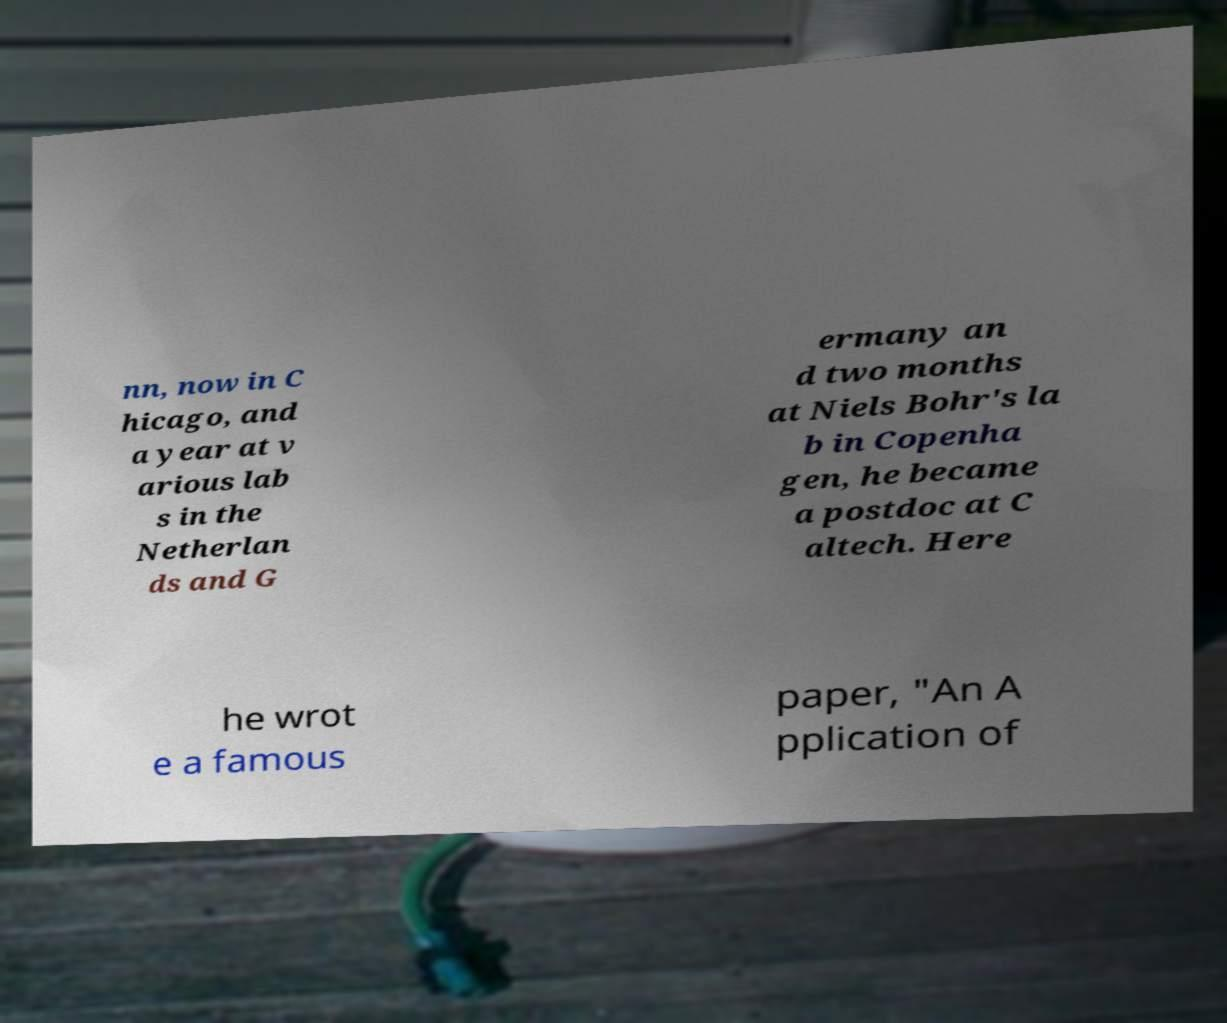Could you assist in decoding the text presented in this image and type it out clearly? nn, now in C hicago, and a year at v arious lab s in the Netherlan ds and G ermany an d two months at Niels Bohr's la b in Copenha gen, he became a postdoc at C altech. Here he wrot e a famous paper, "An A pplication of 